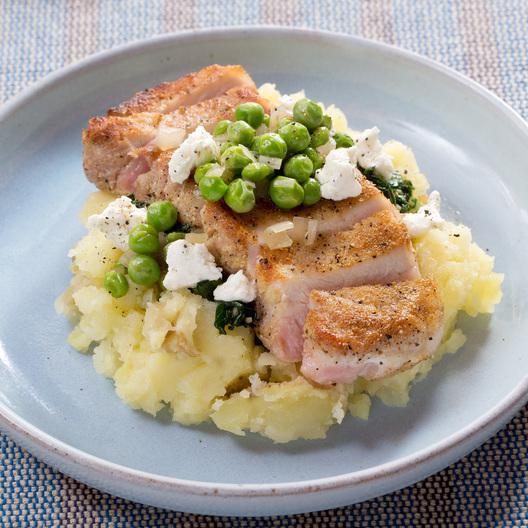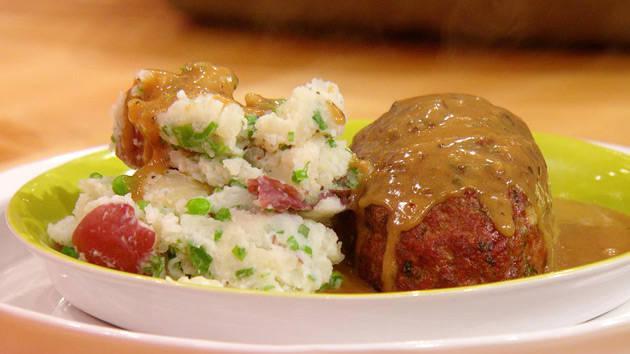The first image is the image on the left, the second image is the image on the right. For the images shown, is this caption "An image shows a round container of food with green peas in a pile on the very top." true? Answer yes or no. Yes. The first image is the image on the left, the second image is the image on the right. Analyze the images presented: Is the assertion "In one image a round white bowl of mashed potatoes is garnished with chives, while a second image shows mashed potatoes with a green garnish served in a dark dish." valid? Answer yes or no. No. 